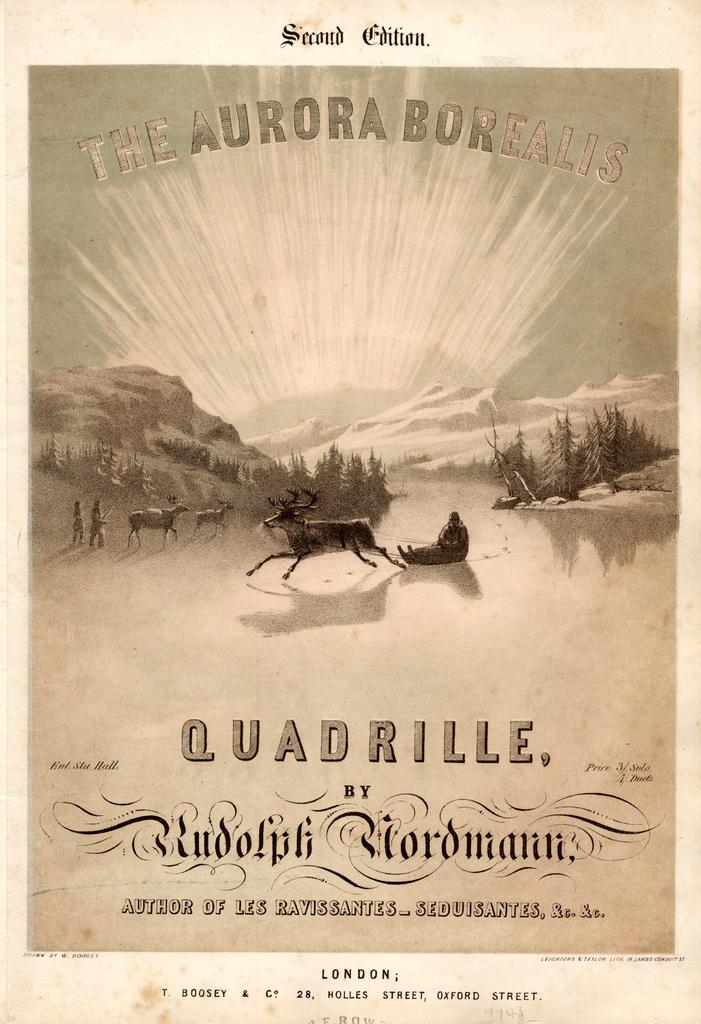<image>
Create a compact narrative representing the image presented. A poster with a reindeer pulling a sled in the center and the title saying The Aurora Borealis by Rodolph Wordmann 